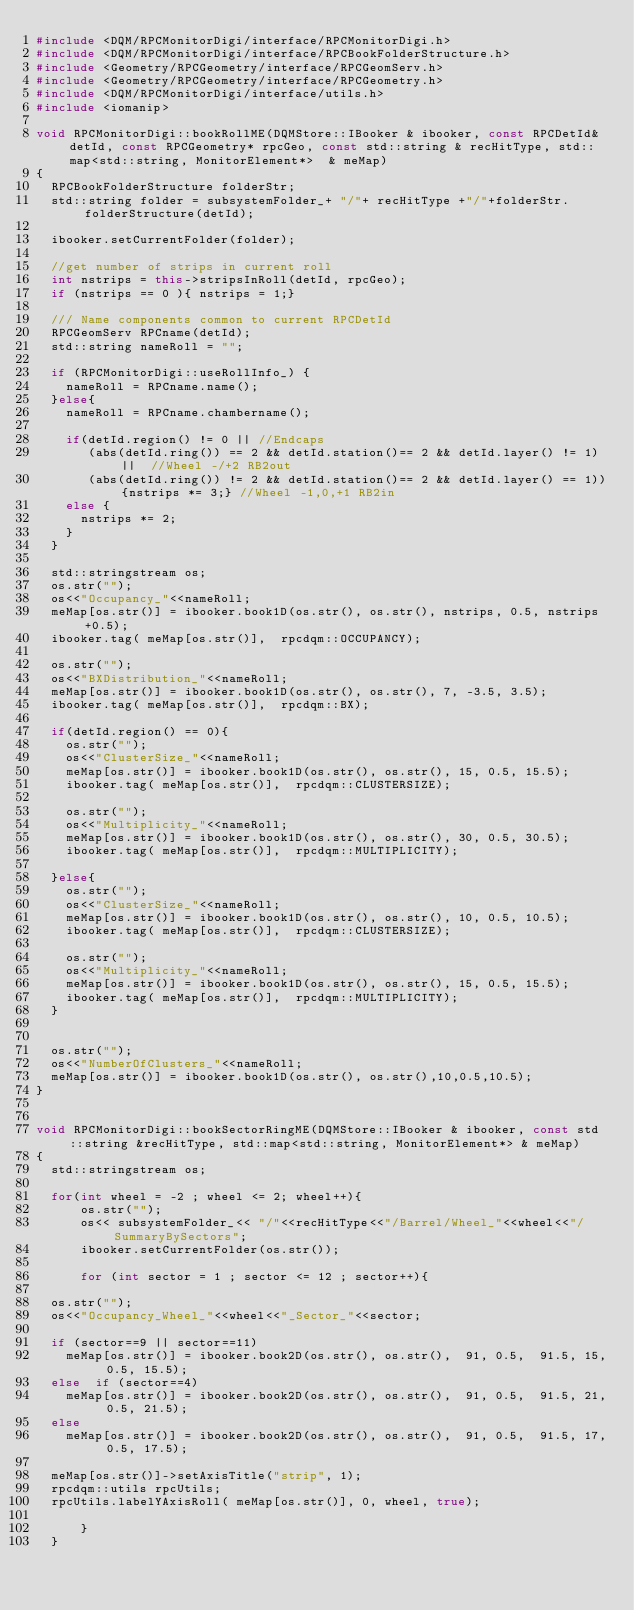Convert code to text. <code><loc_0><loc_0><loc_500><loc_500><_C++_>#include <DQM/RPCMonitorDigi/interface/RPCMonitorDigi.h>
#include <DQM/RPCMonitorDigi/interface/RPCBookFolderStructure.h>
#include <Geometry/RPCGeometry/interface/RPCGeomServ.h>
#include <Geometry/RPCGeometry/interface/RPCGeometry.h>
#include <DQM/RPCMonitorDigi/interface/utils.h>
#include <iomanip>

void RPCMonitorDigi::bookRollME(DQMStore::IBooker & ibooker, const RPCDetId& detId, const RPCGeometry* rpcGeo, const std::string & recHitType, std::map<std::string, MonitorElement*>  & meMap)
{
  RPCBookFolderStructure folderStr;
  std::string folder = subsystemFolder_+ "/"+ recHitType +"/"+folderStr.folderStructure(detId);

  ibooker.setCurrentFolder(folder);
  
  //get number of strips in current roll
  int nstrips = this->stripsInRoll(detId, rpcGeo);
  if (nstrips == 0 ){ nstrips = 1;}

  /// Name components common to current RPCDetId  
  RPCGeomServ RPCname(detId);
  std::string nameRoll = "";
 
  if (RPCMonitorDigi::useRollInfo_) {
    nameRoll = RPCname.name();
  }else{
    nameRoll = RPCname.chambername();
  
    if(detId.region() != 0 || //Endcaps
       (abs(detId.ring()) == 2 && detId.station()== 2 && detId.layer() != 1) ||  //Wheel -/+2 RB2out
       (abs(detId.ring()) != 2 && detId.station()== 2 && detId.layer() == 1)){nstrips *= 3;} //Wheel -1,0,+1 RB2in
    else {
      nstrips *= 2;
    }
  }

  std::stringstream os;
  os.str("");
  os<<"Occupancy_"<<nameRoll;
  meMap[os.str()] = ibooker.book1D(os.str(), os.str(), nstrips, 0.5, nstrips+0.5);
  ibooker.tag( meMap[os.str()],  rpcdqm::OCCUPANCY);

  os.str("");
  os<<"BXDistribution_"<<nameRoll;
  meMap[os.str()] = ibooker.book1D(os.str(), os.str(), 7, -3.5, 3.5);
  ibooker.tag( meMap[os.str()],  rpcdqm::BX);

  if(detId.region() == 0){
    os.str("");
    os<<"ClusterSize_"<<nameRoll;
    meMap[os.str()] = ibooker.book1D(os.str(), os.str(), 15, 0.5, 15.5);
    ibooker.tag( meMap[os.str()],  rpcdqm::CLUSTERSIZE);
    
    os.str("");
    os<<"Multiplicity_"<<nameRoll;
    meMap[os.str()] = ibooker.book1D(os.str(), os.str(), 30, 0.5, 30.5);
    ibooker.tag( meMap[os.str()],  rpcdqm::MULTIPLICITY);

  }else{
    os.str("");
    os<<"ClusterSize_"<<nameRoll;
    meMap[os.str()] = ibooker.book1D(os.str(), os.str(), 10, 0.5, 10.5);
    ibooker.tag( meMap[os.str()],  rpcdqm::CLUSTERSIZE);
    
    os.str("");
    os<<"Multiplicity_"<<nameRoll;
    meMap[os.str()] = ibooker.book1D(os.str(), os.str(), 15, 0.5, 15.5);
    ibooker.tag( meMap[os.str()],  rpcdqm::MULTIPLICITY);
  }

  
  os.str("");
  os<<"NumberOfClusters_"<<nameRoll;
  meMap[os.str()] = ibooker.book1D(os.str(), os.str(),10,0.5,10.5);
}


void RPCMonitorDigi::bookSectorRingME(DQMStore::IBooker & ibooker, const std::string &recHitType, std::map<std::string, MonitorElement*> & meMap)
{ 
  std::stringstream os;
 
  for(int wheel = -2 ; wheel <= 2; wheel++){
      os.str("");     
      os<< subsystemFolder_<< "/"<<recHitType<<"/Barrel/Wheel_"<<wheel<<"/SummaryBySectors";
      ibooker.setCurrentFolder(os.str());
      
      for (int sector = 1 ; sector <= 12 ; sector++){
	
	os.str("");
	os<<"Occupancy_Wheel_"<<wheel<<"_Sector_"<<sector;
    
	if (sector==9 || sector==11)
	  meMap[os.str()] = ibooker.book2D(os.str(), os.str(),  91, 0.5,  91.5, 15, 0.5, 15.5);
	else  if (sector==4) 
	  meMap[os.str()] = ibooker.book2D(os.str(), os.str(),  91, 0.5,  91.5, 21, 0.5, 21.5);
	else
	  meMap[os.str()] = ibooker.book2D(os.str(), os.str(),  91, 0.5,  91.5, 17, 0.5, 17.5);
	
	meMap[os.str()]->setAxisTitle("strip", 1);
	rpcdqm::utils rpcUtils;
	rpcUtils.labelYAxisRoll( meMap[os.str()], 0, wheel, true);
	
      }
  }

</code> 